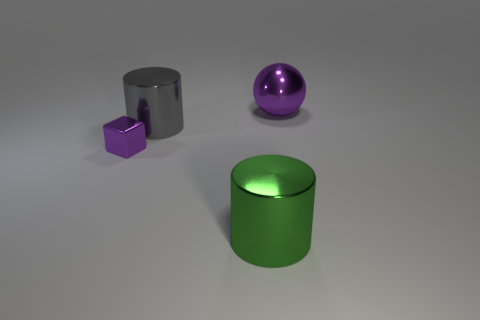Is the material of the large green thing the same as the cube?
Your response must be concise. Yes. What number of things are either tiny purple metal blocks or yellow metallic cubes?
Provide a short and direct response. 1. There is a purple thing to the left of the shiny sphere; what is its shape?
Provide a succinct answer. Cube. What is the color of the big ball that is the same material as the block?
Offer a terse response. Purple. What material is the other large thing that is the same shape as the large gray metal object?
Provide a short and direct response. Metal. What is the shape of the tiny purple metallic thing?
Make the answer very short. Cube. The large green thing that is the same material as the purple block is what shape?
Offer a very short reply. Cylinder. There is a purple cube that is the same material as the big green cylinder; what size is it?
Provide a short and direct response. Small. There is a shiny thing that is both on the left side of the green cylinder and in front of the gray cylinder; what shape is it?
Provide a succinct answer. Cube. What size is the purple metallic thing that is to the left of the shiny object that is in front of the tiny purple block?
Your answer should be compact. Small. 